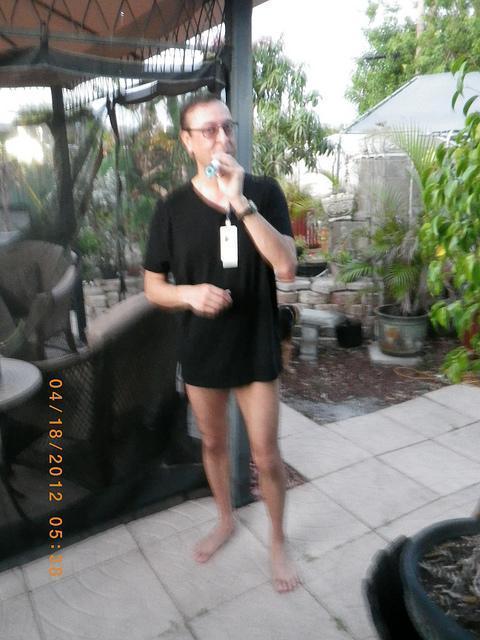How many chairs can you see?
Give a very brief answer. 2. How many potted plants can be seen?
Give a very brief answer. 3. How many people are in the photo?
Give a very brief answer. 1. 